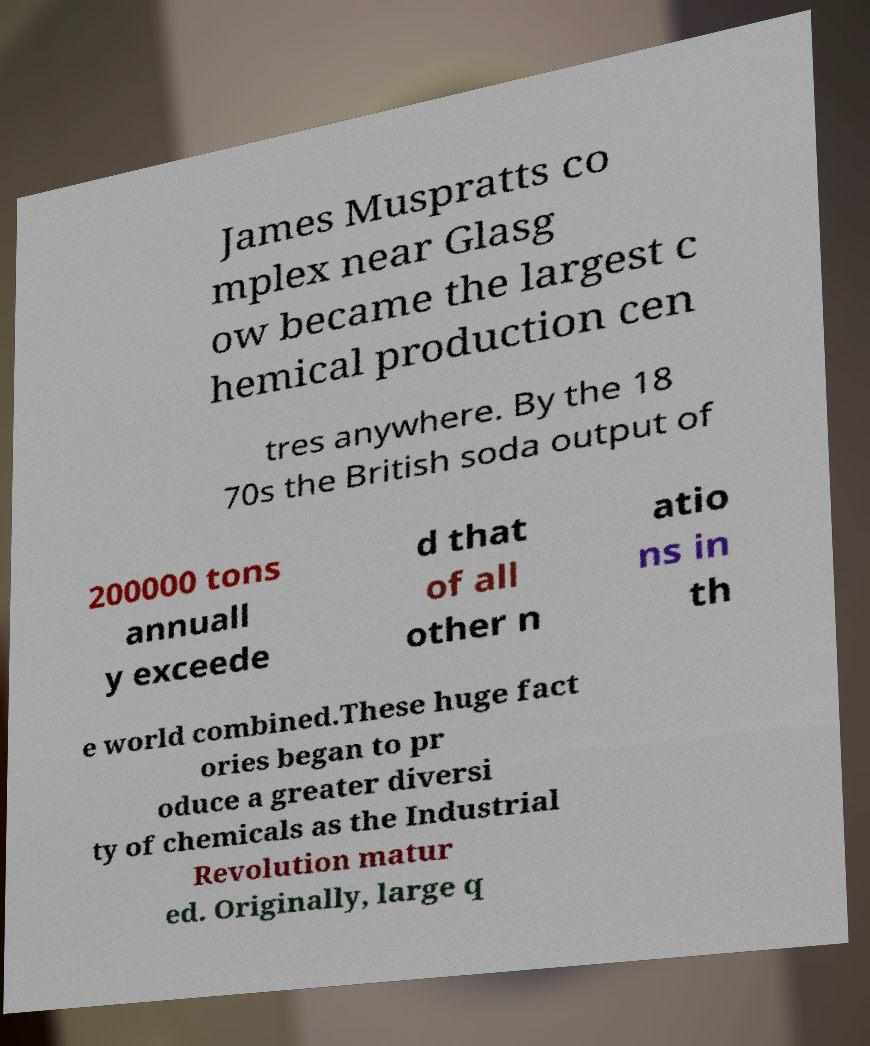What messages or text are displayed in this image? I need them in a readable, typed format. James Muspratts co mplex near Glasg ow became the largest c hemical production cen tres anywhere. By the 18 70s the British soda output of 200000 tons annuall y exceede d that of all other n atio ns in th e world combined.These huge fact ories began to pr oduce a greater diversi ty of chemicals as the Industrial Revolution matur ed. Originally, large q 